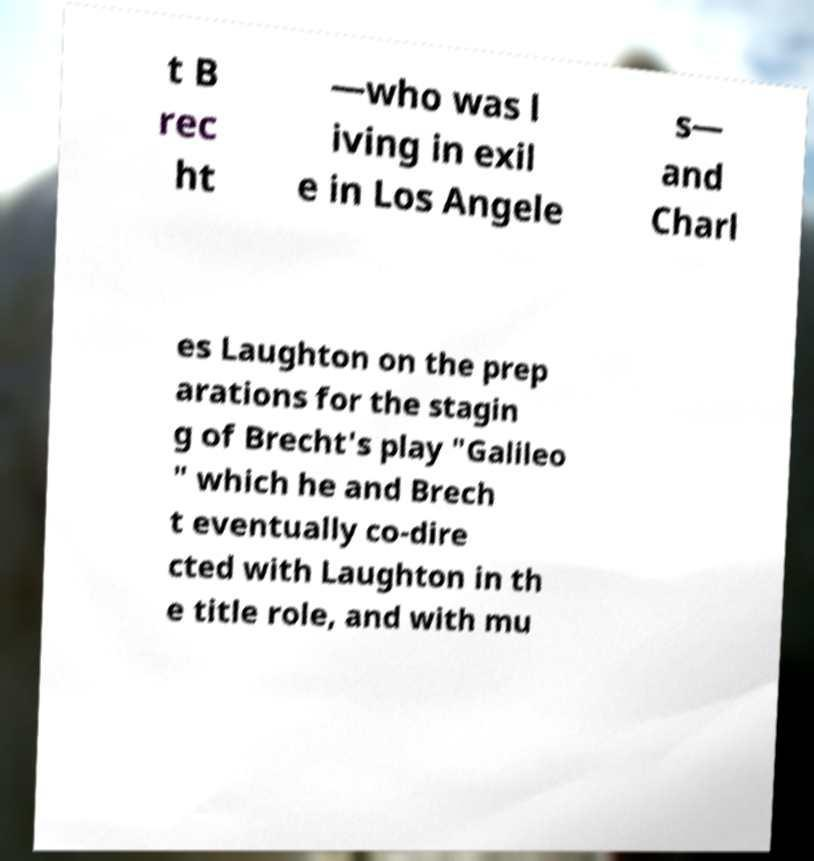There's text embedded in this image that I need extracted. Can you transcribe it verbatim? t B rec ht —who was l iving in exil e in Los Angele s— and Charl es Laughton on the prep arations for the stagin g of Brecht's play "Galileo " which he and Brech t eventually co-dire cted with Laughton in th e title role, and with mu 